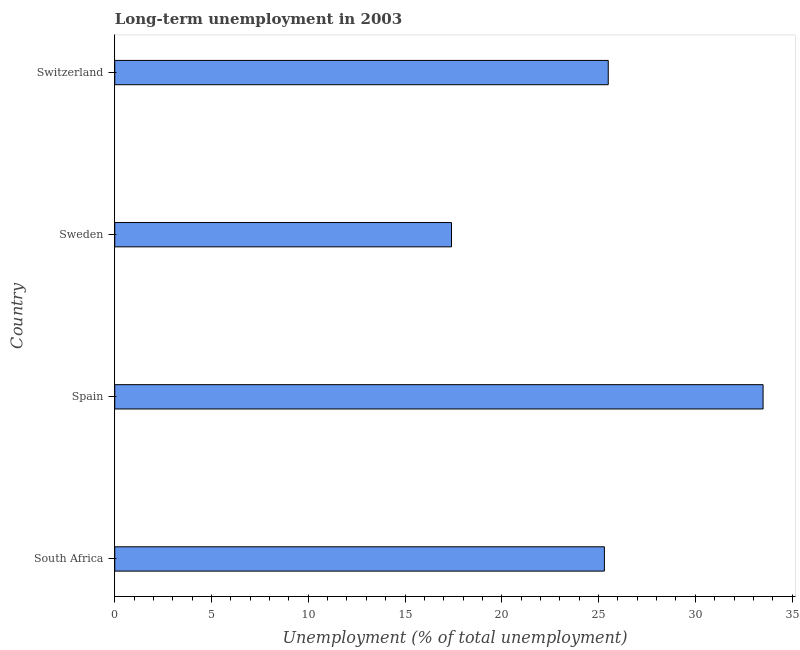What is the title of the graph?
Provide a short and direct response. Long-term unemployment in 2003. What is the label or title of the X-axis?
Give a very brief answer. Unemployment (% of total unemployment). What is the label or title of the Y-axis?
Keep it short and to the point. Country. What is the long-term unemployment in Spain?
Ensure brevity in your answer.  33.5. Across all countries, what is the maximum long-term unemployment?
Ensure brevity in your answer.  33.5. Across all countries, what is the minimum long-term unemployment?
Make the answer very short. 17.4. In which country was the long-term unemployment maximum?
Give a very brief answer. Spain. What is the sum of the long-term unemployment?
Your answer should be compact. 101.7. What is the average long-term unemployment per country?
Provide a succinct answer. 25.43. What is the median long-term unemployment?
Keep it short and to the point. 25.4. What is the ratio of the long-term unemployment in Spain to that in Switzerland?
Offer a terse response. 1.31. Is the difference between the long-term unemployment in Spain and Switzerland greater than the difference between any two countries?
Your answer should be very brief. No. What is the difference between the highest and the second highest long-term unemployment?
Your response must be concise. 8. Is the sum of the long-term unemployment in Spain and Sweden greater than the maximum long-term unemployment across all countries?
Give a very brief answer. Yes. What is the difference between the highest and the lowest long-term unemployment?
Your answer should be compact. 16.1. How many countries are there in the graph?
Provide a short and direct response. 4. What is the difference between two consecutive major ticks on the X-axis?
Your response must be concise. 5. Are the values on the major ticks of X-axis written in scientific E-notation?
Give a very brief answer. No. What is the Unemployment (% of total unemployment) in South Africa?
Make the answer very short. 25.3. What is the Unemployment (% of total unemployment) in Spain?
Offer a very short reply. 33.5. What is the Unemployment (% of total unemployment) in Sweden?
Provide a succinct answer. 17.4. What is the difference between the Unemployment (% of total unemployment) in South Africa and Spain?
Offer a terse response. -8.2. What is the ratio of the Unemployment (% of total unemployment) in South Africa to that in Spain?
Your answer should be compact. 0.76. What is the ratio of the Unemployment (% of total unemployment) in South Africa to that in Sweden?
Ensure brevity in your answer.  1.45. What is the ratio of the Unemployment (% of total unemployment) in Spain to that in Sweden?
Your answer should be very brief. 1.93. What is the ratio of the Unemployment (% of total unemployment) in Spain to that in Switzerland?
Provide a succinct answer. 1.31. What is the ratio of the Unemployment (% of total unemployment) in Sweden to that in Switzerland?
Your response must be concise. 0.68. 